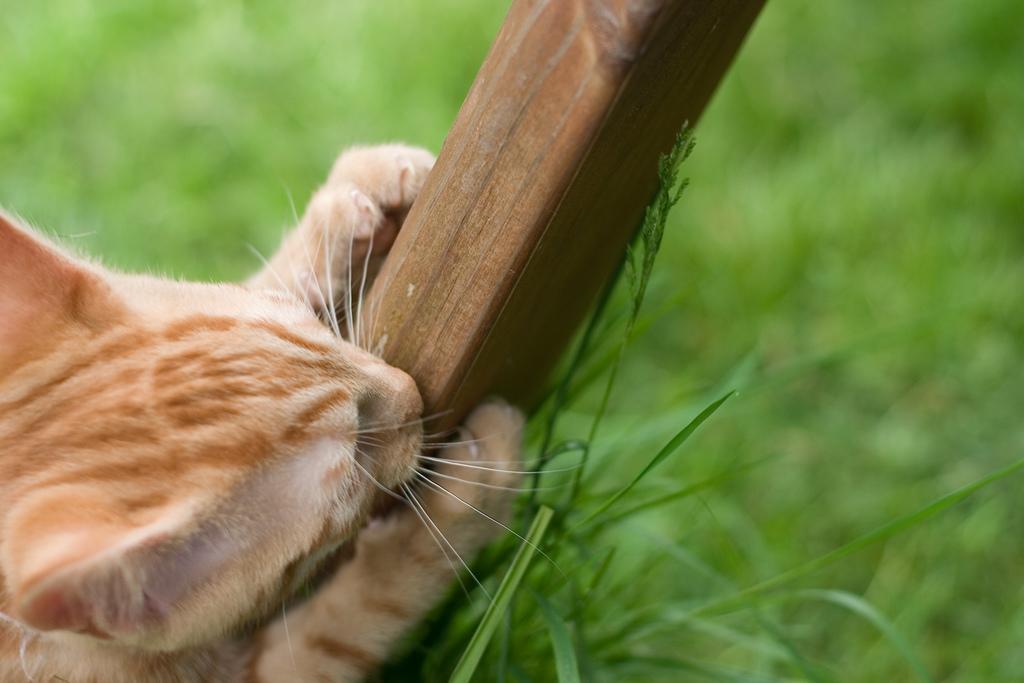In one or two sentences, can you explain what this image depicts? In this picture I can see there is a cat holding a wooden stick and there is grass on the floor and the backdrop is blurred. 